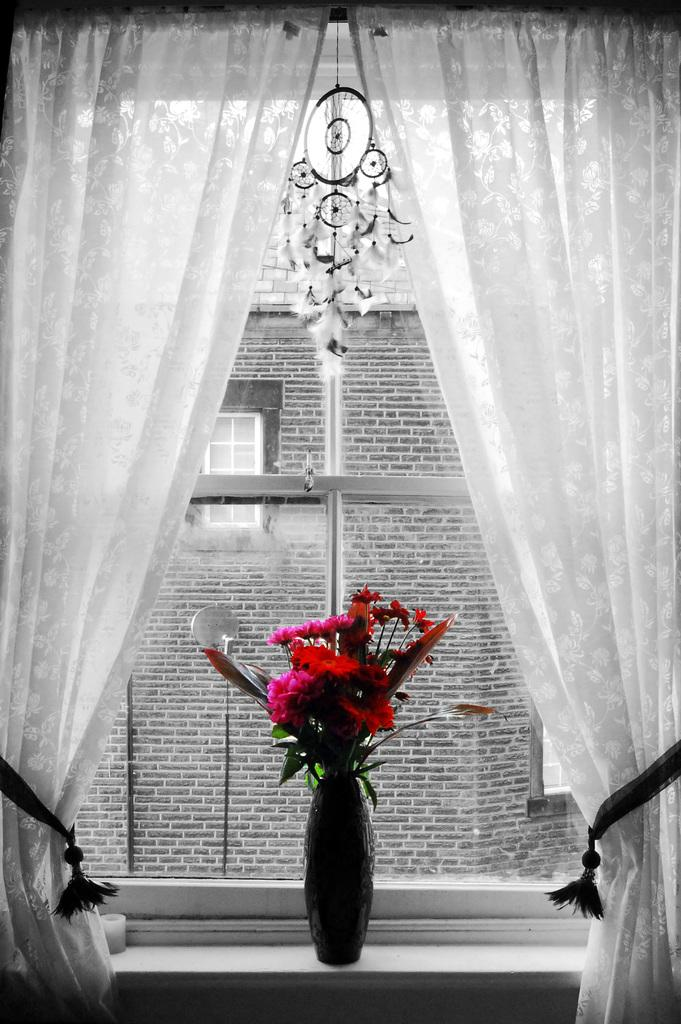What is in the vase that is visible in the image? The vase contains red flowers. Where is the vase located in the image? The vase is placed in a window. What can be seen in the background of the image? There is a building visible in the background of the image. What type of window treatment is present in the image? There are white curtains in the image. Can you tell me how many pieces of popcorn are on the side of the vase in the image? There is no popcorn present in the image, and therefore no such detail can be observed. 